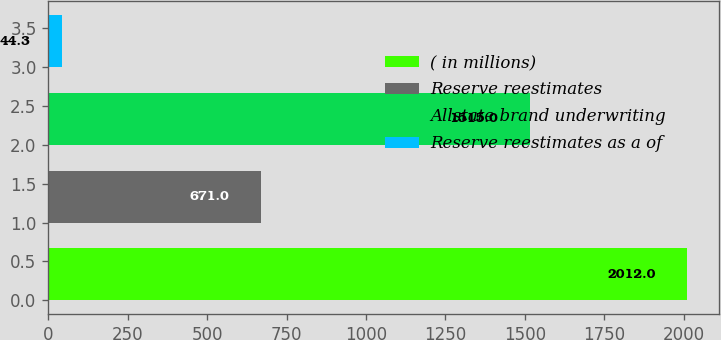Convert chart to OTSL. <chart><loc_0><loc_0><loc_500><loc_500><bar_chart><fcel>( in millions)<fcel>Reserve reestimates<fcel>Allstate brand underwriting<fcel>Reserve reestimates as a of<nl><fcel>2012<fcel>671<fcel>1515<fcel>44.3<nl></chart> 